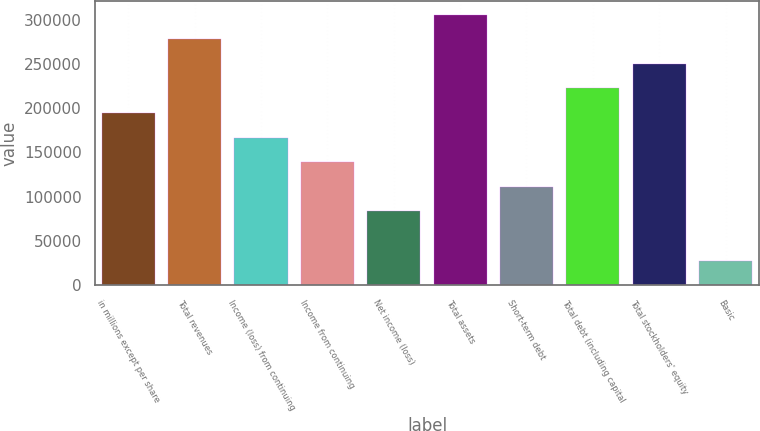Convert chart. <chart><loc_0><loc_0><loc_500><loc_500><bar_chart><fcel>in millions except per share<fcel>Total revenues<fcel>Income (loss) from continuing<fcel>Income from continuing<fcel>Net income (loss)<fcel>Total assets<fcel>Short-term debt<fcel>Total debt (including capital<fcel>Total stockholders' equity<fcel>Basic<nl><fcel>194519<fcel>277884<fcel>166731<fcel>138942<fcel>83365.4<fcel>305672<fcel>111154<fcel>222307<fcel>250096<fcel>27788.7<nl></chart> 